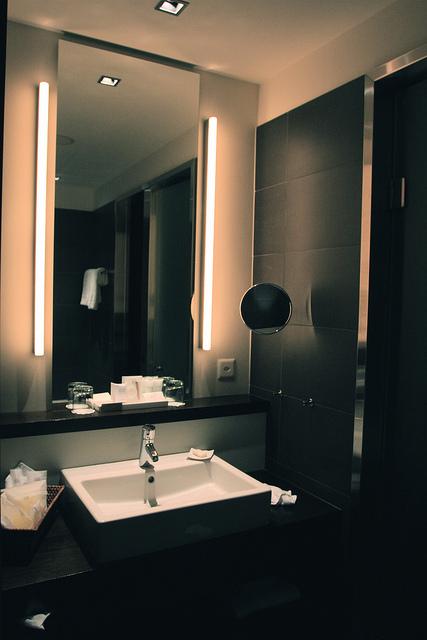Where is the sink?
Give a very brief answer. Bathroom. Is there a mirror?
Concise answer only. Yes. How many mirrors are there?
Keep it brief. 1. 